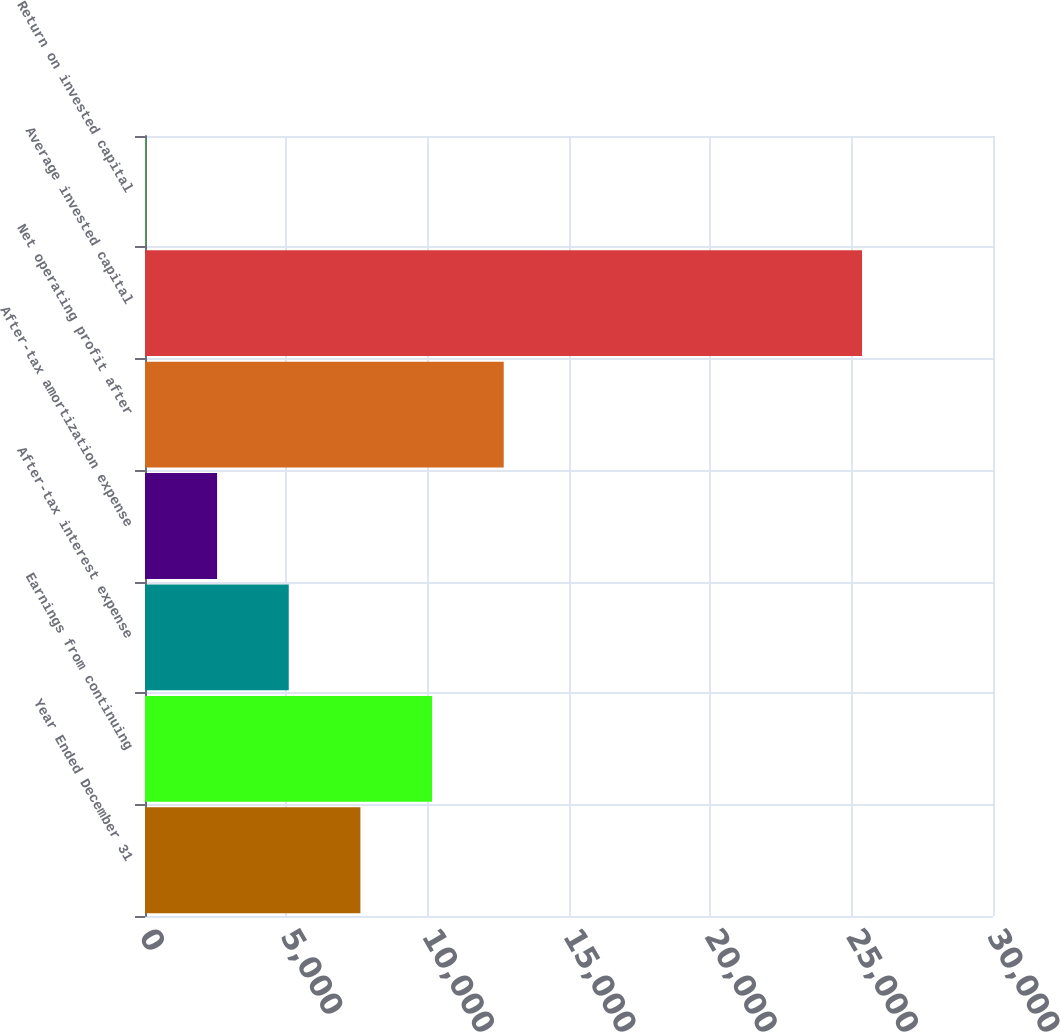Convert chart to OTSL. <chart><loc_0><loc_0><loc_500><loc_500><bar_chart><fcel>Year Ended December 31<fcel>Earnings from continuing<fcel>After-tax interest expense<fcel>After-tax amortization expense<fcel>Net operating profit after<fcel>Average invested capital<fcel>Return on invested capital<nl><fcel>7620.74<fcel>10155.9<fcel>5085.56<fcel>2550.38<fcel>12691.1<fcel>25367<fcel>15.2<nl></chart> 